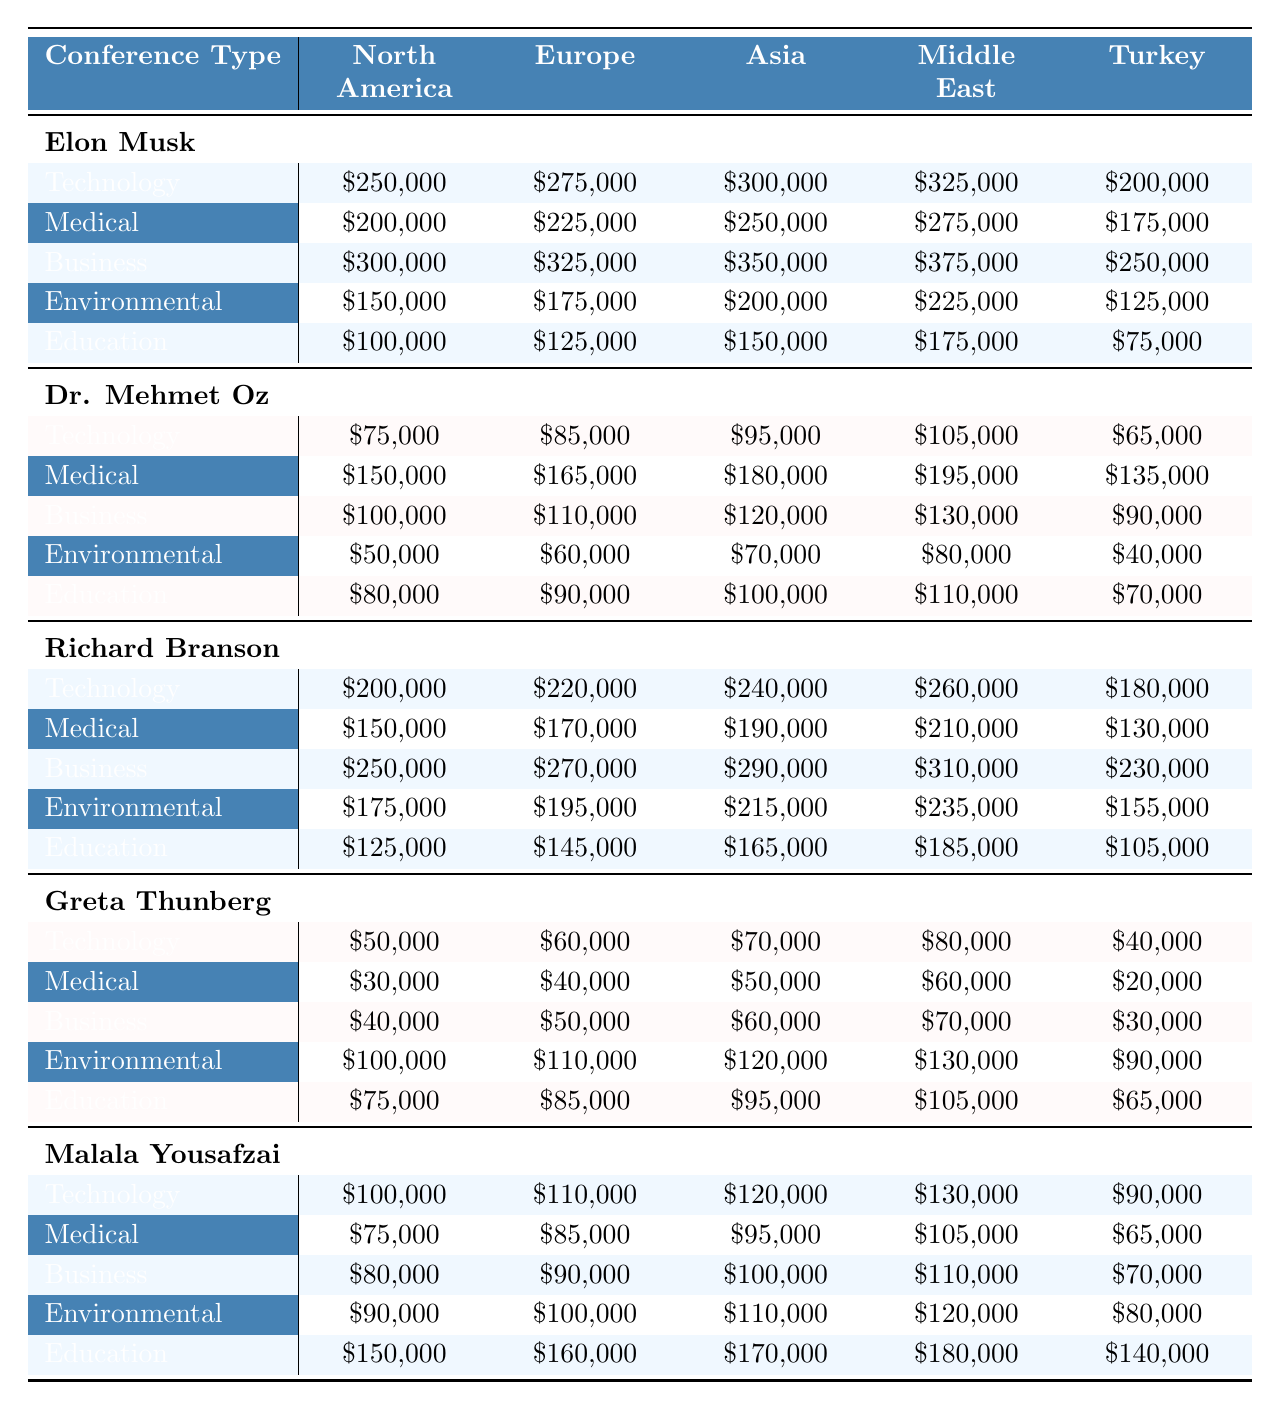What is the highest speaker fee for the Business conference type in North America? In the North America column under the Business row, the highest fee is for Elon Musk at \$300,000.
Answer: \$300,000 Which speaker has the lowest fee for Environmental conferences in Turkey? The fees for Environmental conferences in Turkey are as follows: Elon Musk is \$125,000, Dr. Mehmet Oz is \$40,000, Richard Branson is \$155,000, Greta Thunberg is \$90,000, and Malala Yousafzai is \$80,000. The lowest fee is Dr. Mehmet Oz at \$40,000.
Answer: \$40,000 What is the total speaker fee for Elon Musk across all conference types in Europe? The individual fees for Elon Musk in Europe are: Technology \$275,000, Medical \$225,000, Business \$325,000, Environmental \$175,000, Education \$125,000. Adding these gives \$275,000 + \$225,000 + \$325,000 + \$175,000 + \$125,000 = \$1,125,000.
Answer: \$1,125,000 Is it true that Greta Thunberg has a higher fee for Education conferences than Malala Yousafzai in Europe? The fees are \$85,000 for Greta Thunberg and \$160,000 for Malala Yousafzai in Europe. Since \$85,000 is less than \$160,000, the statement is false.
Answer: No What is the average speaker fee for the Medical conference type in Asia? The fees for the Medical conference type in Asia are: Elon Musk \$250,000, Dr. Mehmet Oz \$180,000, Richard Branson \$190,000, Greta Thunberg \$50,000, Malala Yousafzai \$95,000. The total is \$250,000 + \$180,000 + \$190,000 + \$50,000 + \$95,000 = \$765,000. The average is \$765,000 / 5 = \$153,000.
Answer: \$153,000 Which speaker has the highest fee for Technology conferences in Asia? Looking at the Technology fees in Asia: Elon Musk \$300,000, Dr. Mehmet Oz \$95,000, Richard Branson \$240,000, Greta Thunberg \$70,000, Malala Yousafzai \$120,000. The highest fee is Elon Musk at \$300,000.
Answer: \$300,000 What is the difference in fees between the highest and lowest speaker for Environmental conferences in North America? For Environmental conferences in North America, the highest fee is from Richard Branson at \$175,000 and the lowest fee is from Greta Thunberg at \$100,000. The difference is \$175,000 - \$100,000 = \$75,000.
Answer: \$75,000 Which region has the highest overall fees for Business conferences across all speakers? The fees for Business in each region are: North America total \$300,000, Europe total \$325,000 (Elon Musk), Asia total \$290,000 (Richard Branson), Middle East total \$375,000 (Elon Musk), Turkey total \$250,000. The highest is the Middle East at \$375,000.
Answer: Middle East What is the total fee for all speakers across all types of conferences in Europe? Calculating the fees by summing each speaker's total in Europe: Elon Musk \$1,125,000, Dr. Mehmet Oz \$425,000, Richard Branson \$1,085,000, Greta Thunberg \$335,000, Malala Yousafzai \$700,000. Total is \$1,125,000 + \$425,000 + \$1,085,000 + \$335,000 + \$700,000 = \$3,670,000.
Answer: \$3,670,000 